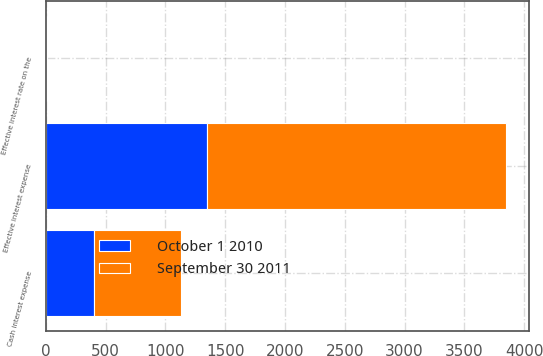Convert chart. <chart><loc_0><loc_0><loc_500><loc_500><stacked_bar_chart><ecel><fcel>Effective interest rate on the<fcel>Cash interest expense<fcel>Effective interest expense<nl><fcel>October 1 2010<fcel>6.86<fcel>400<fcel>1345<nl><fcel>September 30 2011<fcel>6.86<fcel>734<fcel>2502<nl></chart> 